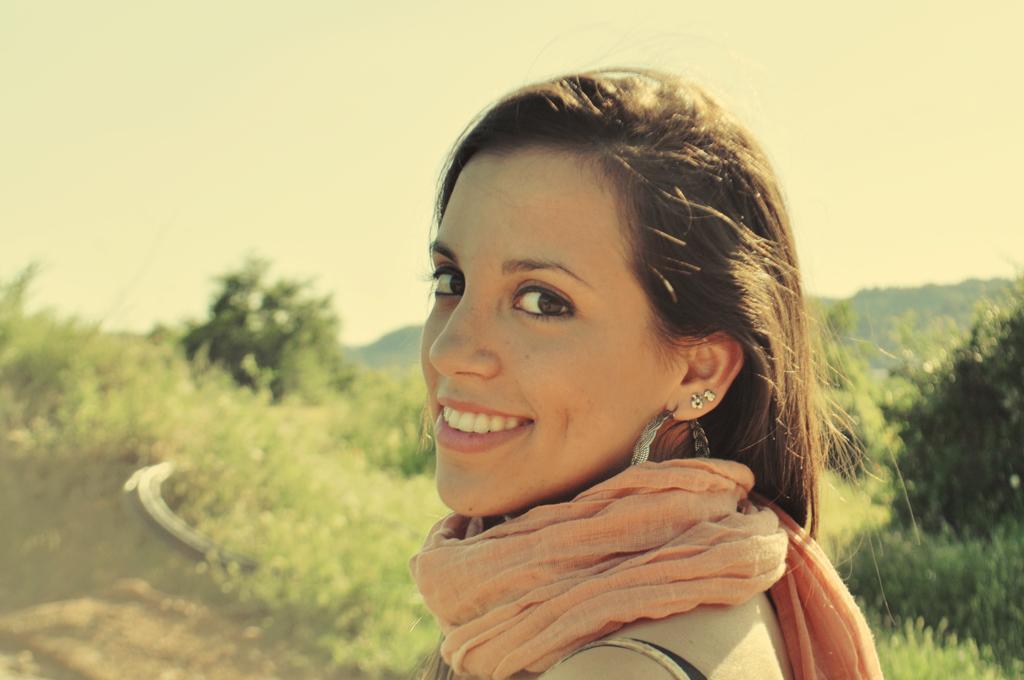How would you summarize this image in a sentence or two? In the middle of the image a woman is standing and smiling. Behind her there are some trees. At the top of the image there is sky. 